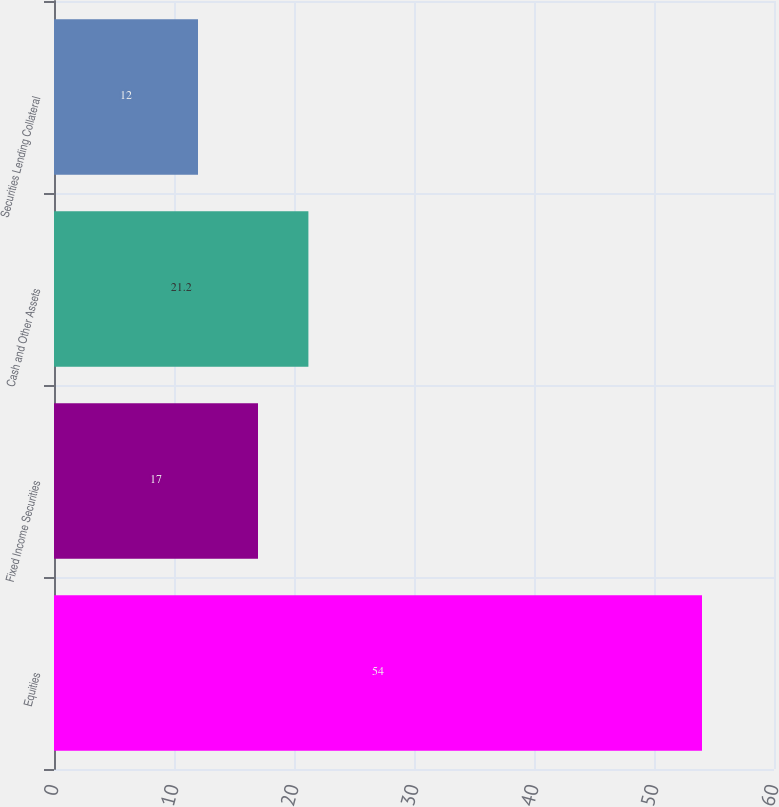Convert chart. <chart><loc_0><loc_0><loc_500><loc_500><bar_chart><fcel>Equities<fcel>Fixed Income Securities<fcel>Cash and Other Assets<fcel>Securities Lending Collateral<nl><fcel>54<fcel>17<fcel>21.2<fcel>12<nl></chart> 